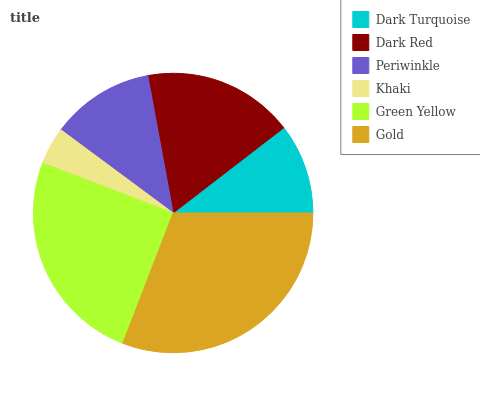Is Khaki the minimum?
Answer yes or no. Yes. Is Gold the maximum?
Answer yes or no. Yes. Is Dark Red the minimum?
Answer yes or no. No. Is Dark Red the maximum?
Answer yes or no. No. Is Dark Red greater than Dark Turquoise?
Answer yes or no. Yes. Is Dark Turquoise less than Dark Red?
Answer yes or no. Yes. Is Dark Turquoise greater than Dark Red?
Answer yes or no. No. Is Dark Red less than Dark Turquoise?
Answer yes or no. No. Is Dark Red the high median?
Answer yes or no. Yes. Is Periwinkle the low median?
Answer yes or no. Yes. Is Khaki the high median?
Answer yes or no. No. Is Green Yellow the low median?
Answer yes or no. No. 